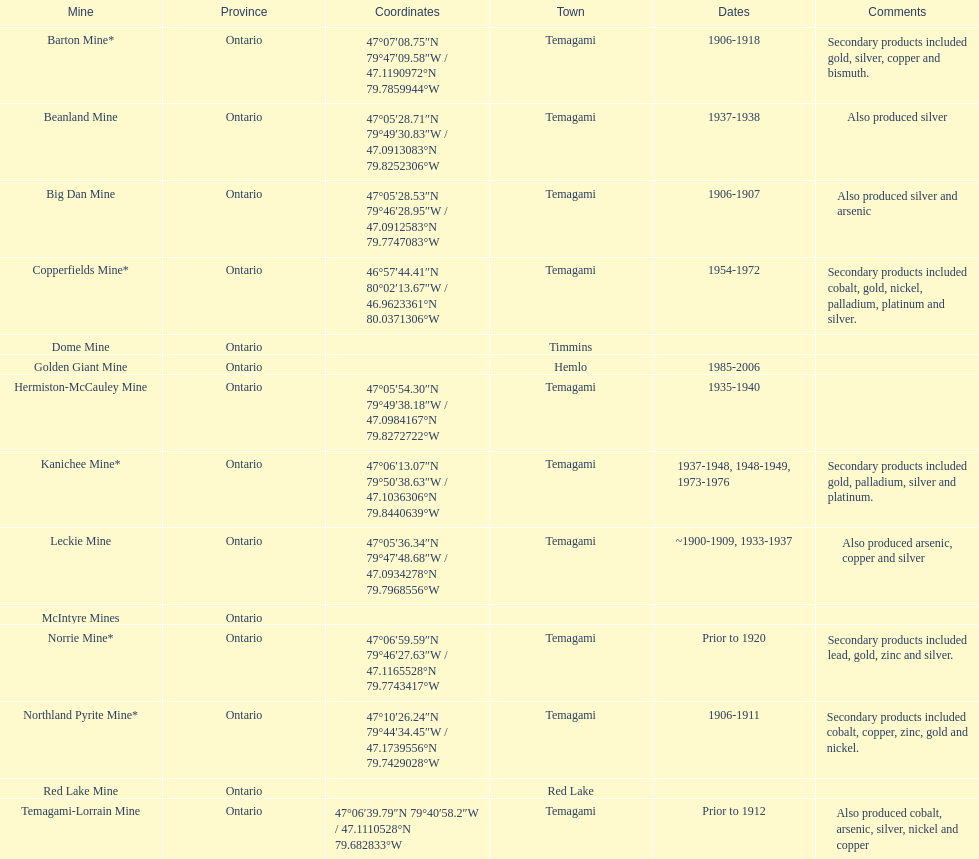Where can bismuth be found in a mine? Barton Mine. 